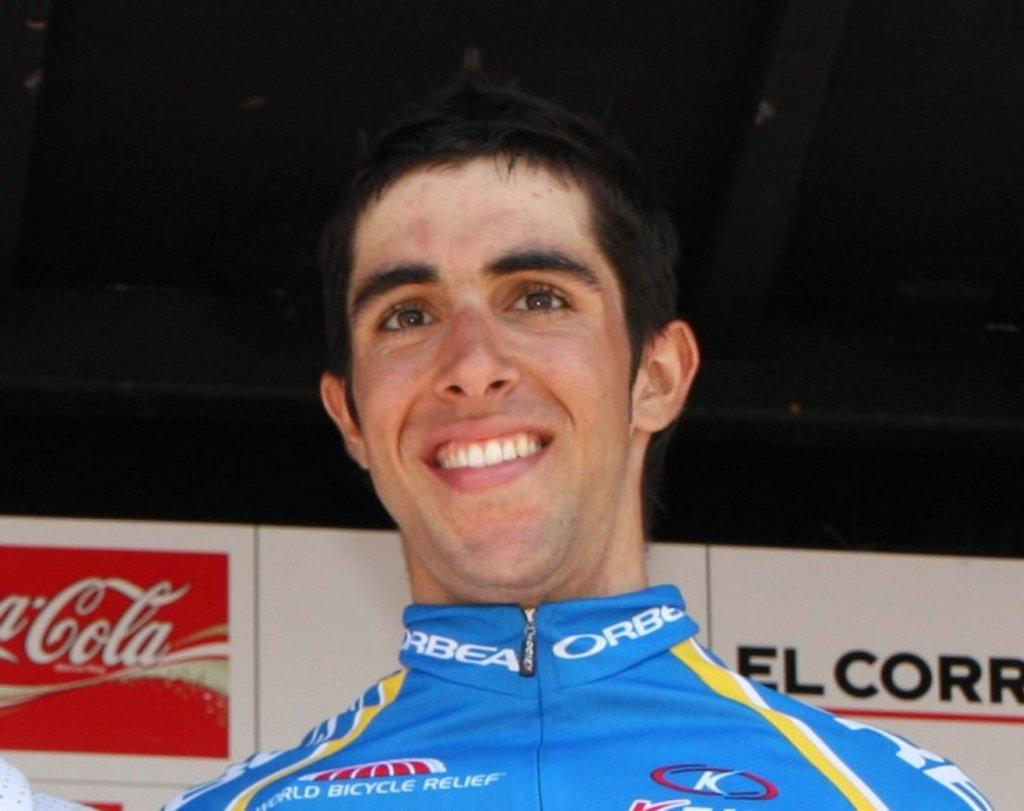<image>
Summarize the visual content of the image. A man wearing a racing uniform is smiling in front of a Coca-Cola sign. 